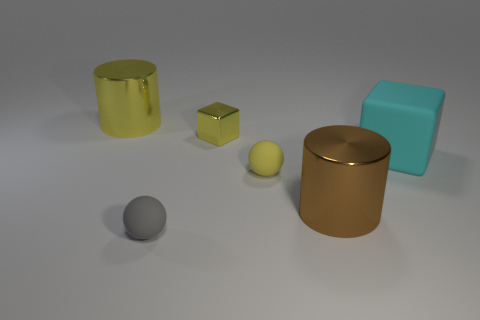Subtract 1 spheres. How many spheres are left? 1 Add 3 large blocks. How many objects exist? 9 Subtract all gray balls. How many balls are left? 1 Subtract all gray cylinders. Subtract all red cubes. How many cylinders are left? 2 Subtract all gray balls. How many yellow cubes are left? 1 Subtract all matte balls. Subtract all large yellow metallic cylinders. How many objects are left? 3 Add 4 small yellow matte objects. How many small yellow matte objects are left? 5 Add 6 cylinders. How many cylinders exist? 8 Subtract 1 brown cylinders. How many objects are left? 5 Subtract all cylinders. How many objects are left? 4 